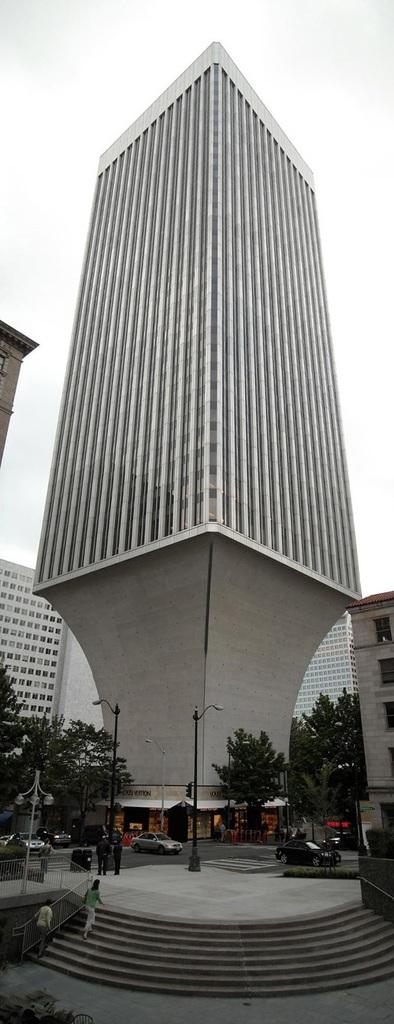Who or what can be seen in the image? There are persons in the image. What else is present in the image besides the persons? There are cars, trees, buildings, and the sky visible in the image. Where are the trees located in the image? The trees are present at the bottom of the image. What is the background of the image? The sky is visible in the background of the image. What type of holiday is being celebrated in the image? There is no indication of a holiday being celebrated in the image. How much credit is being given to the person in the image? There is no mention of credit or any financial transaction in the image. 